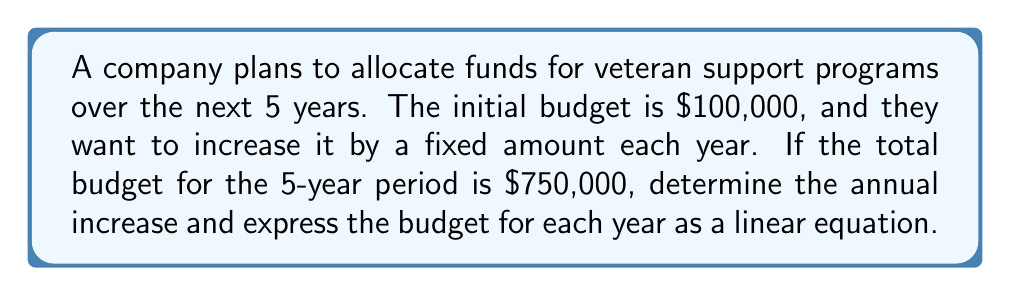Can you solve this math problem? Let's approach this step-by-step:

1) Let $x$ be the annual increase in budget.

2) The budget for each year can be expressed as:
   Year 1: $100,000$
   Year 2: $100,000 + x$
   Year 3: $100,000 + 2x$
   Year 4: $100,000 + 3x$
   Year 5: $100,000 + 4x$

3) The total budget for 5 years is $750,000. We can set up an equation:

   $$(100,000) + (100,000 + x) + (100,000 + 2x) + (100,000 + 3x) + (100,000 + 4x) = 750,000$$

4) Simplify the left side of the equation:

   $$500,000 + 10x = 750,000$$

5) Subtract 500,000 from both sides:

   $$10x = 250,000$$

6) Divide both sides by 10:

   $$x = 25,000$$

7) Therefore, the annual increase is $25,000.

8) We can now express the budget for each year as a linear equation:

   $$B(y) = 100,000 + 25,000(y-1)$$

   Where $B(y)$ is the budget for year $y$ (y = 1, 2, 3, 4, 5).

9) This can be simplified to:

   $$B(y) = 75,000 + 25,000y$$
Answer: $B(y) = 75,000 + 25,000y$, where $y$ is the year (1-5) 